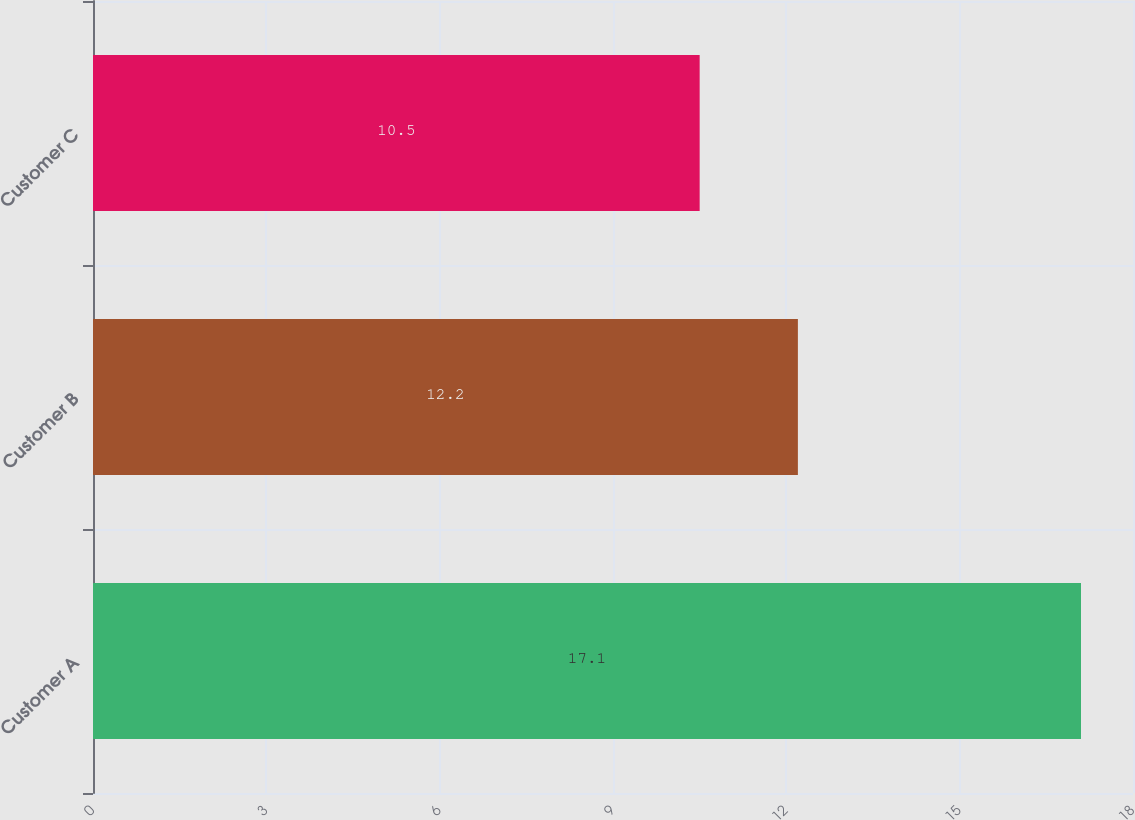Convert chart to OTSL. <chart><loc_0><loc_0><loc_500><loc_500><bar_chart><fcel>Customer A<fcel>Customer B<fcel>Customer C<nl><fcel>17.1<fcel>12.2<fcel>10.5<nl></chart> 